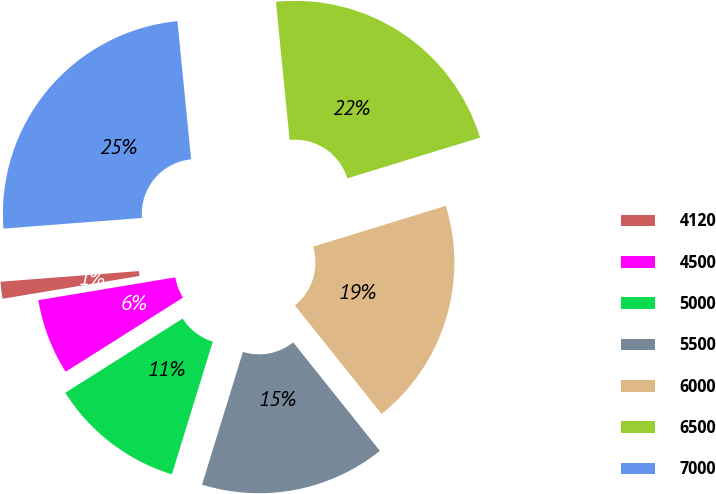Convert chart. <chart><loc_0><loc_0><loc_500><loc_500><pie_chart><fcel>4120<fcel>4500<fcel>5000<fcel>5500<fcel>6000<fcel>6500<fcel>7000<nl><fcel>1.41%<fcel>6.34%<fcel>11.27%<fcel>15.49%<fcel>19.01%<fcel>21.83%<fcel>24.65%<nl></chart> 